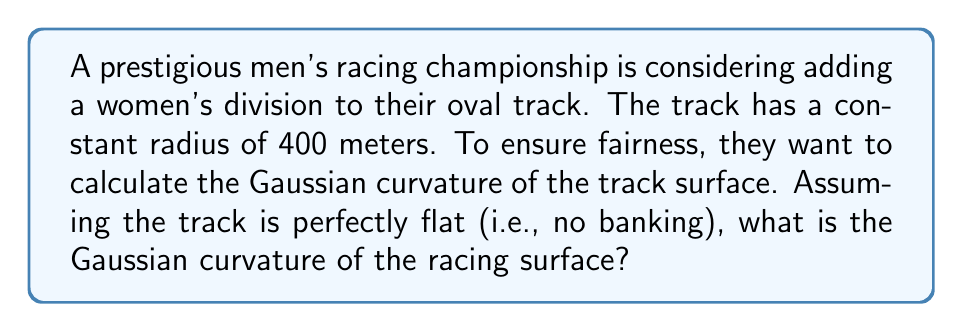Can you answer this question? To solve this problem, we need to understand the concept of Gaussian curvature and how it applies to our racing track. Let's break it down step-by-step:

1) Gaussian curvature is a measure of a surface's curvature at a point. It's the product of the principal curvatures at that point.

2) For a curve in a plane, the curvature at any point is given by:

   $$\kappa = \frac{1}{R}$$

   where $R$ is the radius of curvature.

3) In our case, the track is an oval with a constant radius of 400 meters. So, in the direction of the track, the curvature is:

   $$\kappa_1 = \frac{1}{400} \text{ m}^{-1}$$

4) However, we're told that the track is perfectly flat (no banking). This means that in the direction perpendicular to the track, there is no curvature. We can express this as:

   $$\kappa_2 = 0 \text{ m}^{-1}$$

5) The Gaussian curvature $K$ is the product of these two principal curvatures:

   $$K = \kappa_1 \cdot \kappa_2$$

6) Substituting our values:

   $$K = \frac{1}{400} \cdot 0 = 0 \text{ m}^{-2}$$

Therefore, the Gaussian curvature of the racing surface is zero.

This result is characteristic of developable surfaces, which can be flattened onto a plane without distortion. In this case, we could "unroll" our racetrack into a straight strip without stretching or compressing the surface.
Answer: The Gaussian curvature of the racing surface is 0 m^(-2). 